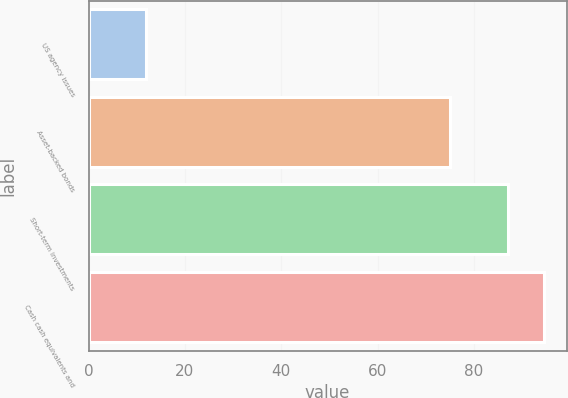<chart> <loc_0><loc_0><loc_500><loc_500><bar_chart><fcel>US agency issues<fcel>Asset-backed bonds<fcel>Short-term investments<fcel>Cash cash equivalents and<nl><fcel>12<fcel>75<fcel>87<fcel>94.5<nl></chart> 